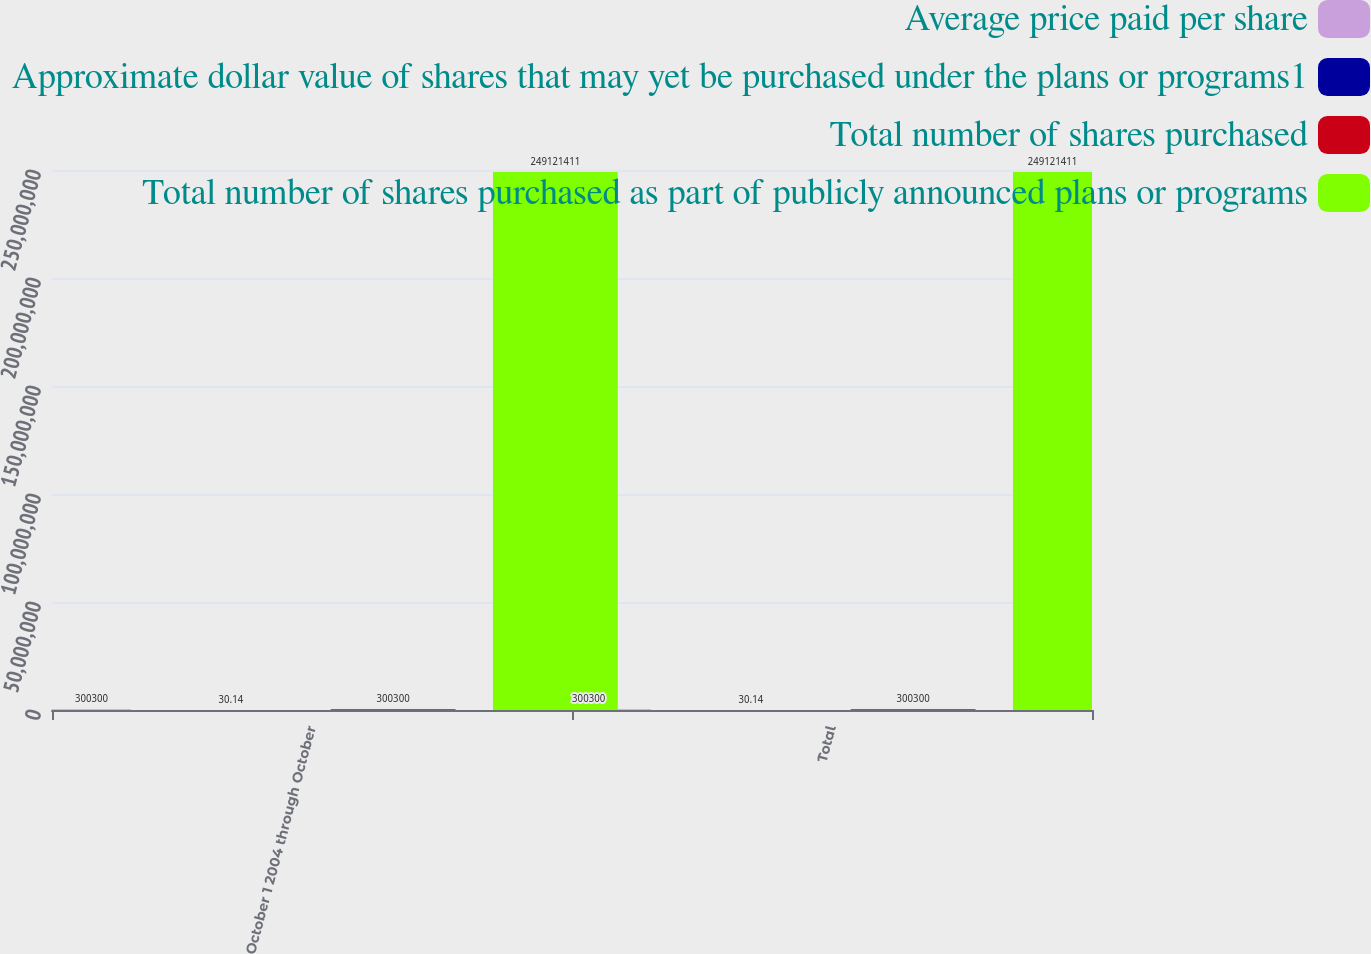Convert chart to OTSL. <chart><loc_0><loc_0><loc_500><loc_500><stacked_bar_chart><ecel><fcel>October 1 2004 through October<fcel>Total<nl><fcel>Average price paid per share<fcel>300300<fcel>300300<nl><fcel>Approximate dollar value of shares that may yet be purchased under the plans or programs1<fcel>30.14<fcel>30.14<nl><fcel>Total number of shares purchased<fcel>300300<fcel>300300<nl><fcel>Total number of shares purchased as part of publicly announced plans or programs<fcel>2.49121e+08<fcel>2.49121e+08<nl></chart> 